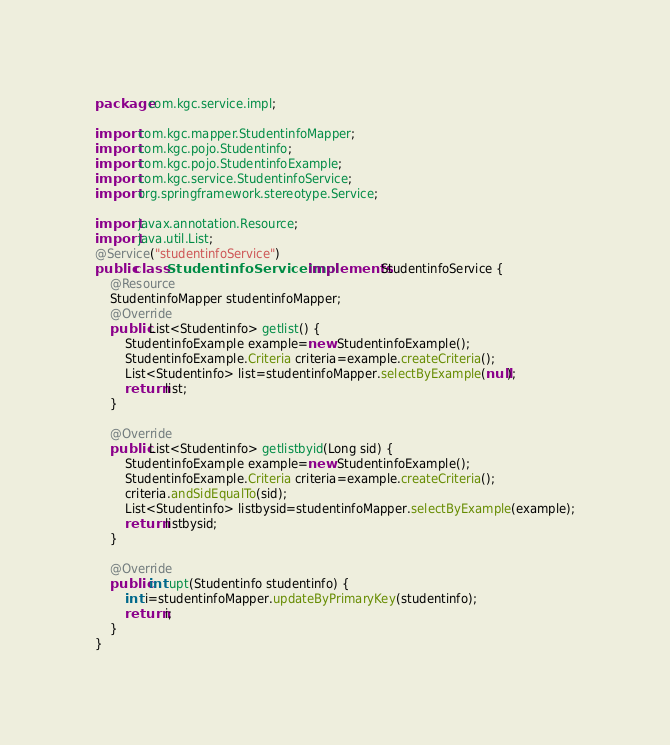<code> <loc_0><loc_0><loc_500><loc_500><_Java_>package com.kgc.service.impl;

import com.kgc.mapper.StudentinfoMapper;
import com.kgc.pojo.Studentinfo;
import com.kgc.pojo.StudentinfoExample;
import com.kgc.service.StudentinfoService;
import org.springframework.stereotype.Service;

import javax.annotation.Resource;
import java.util.List;
@Service("studentinfoService")
public class StudentinfoServiceImpl implements StudentinfoService {
    @Resource
    StudentinfoMapper studentinfoMapper;
    @Override
    public List<Studentinfo> getlist() {
        StudentinfoExample example=new StudentinfoExample();
        StudentinfoExample.Criteria criteria=example.createCriteria();
        List<Studentinfo> list=studentinfoMapper.selectByExample(null);
        return list;
    }

    @Override
    public List<Studentinfo> getlistbyid(Long sid) {
        StudentinfoExample example=new StudentinfoExample();
        StudentinfoExample.Criteria criteria=example.createCriteria();
        criteria.andSidEqualTo(sid);
        List<Studentinfo> listbysid=studentinfoMapper.selectByExample(example);
        return listbysid;
    }

    @Override
    public int upt(Studentinfo studentinfo) {
        int i=studentinfoMapper.updateByPrimaryKey(studentinfo);
        return i;
    }
}
</code> 